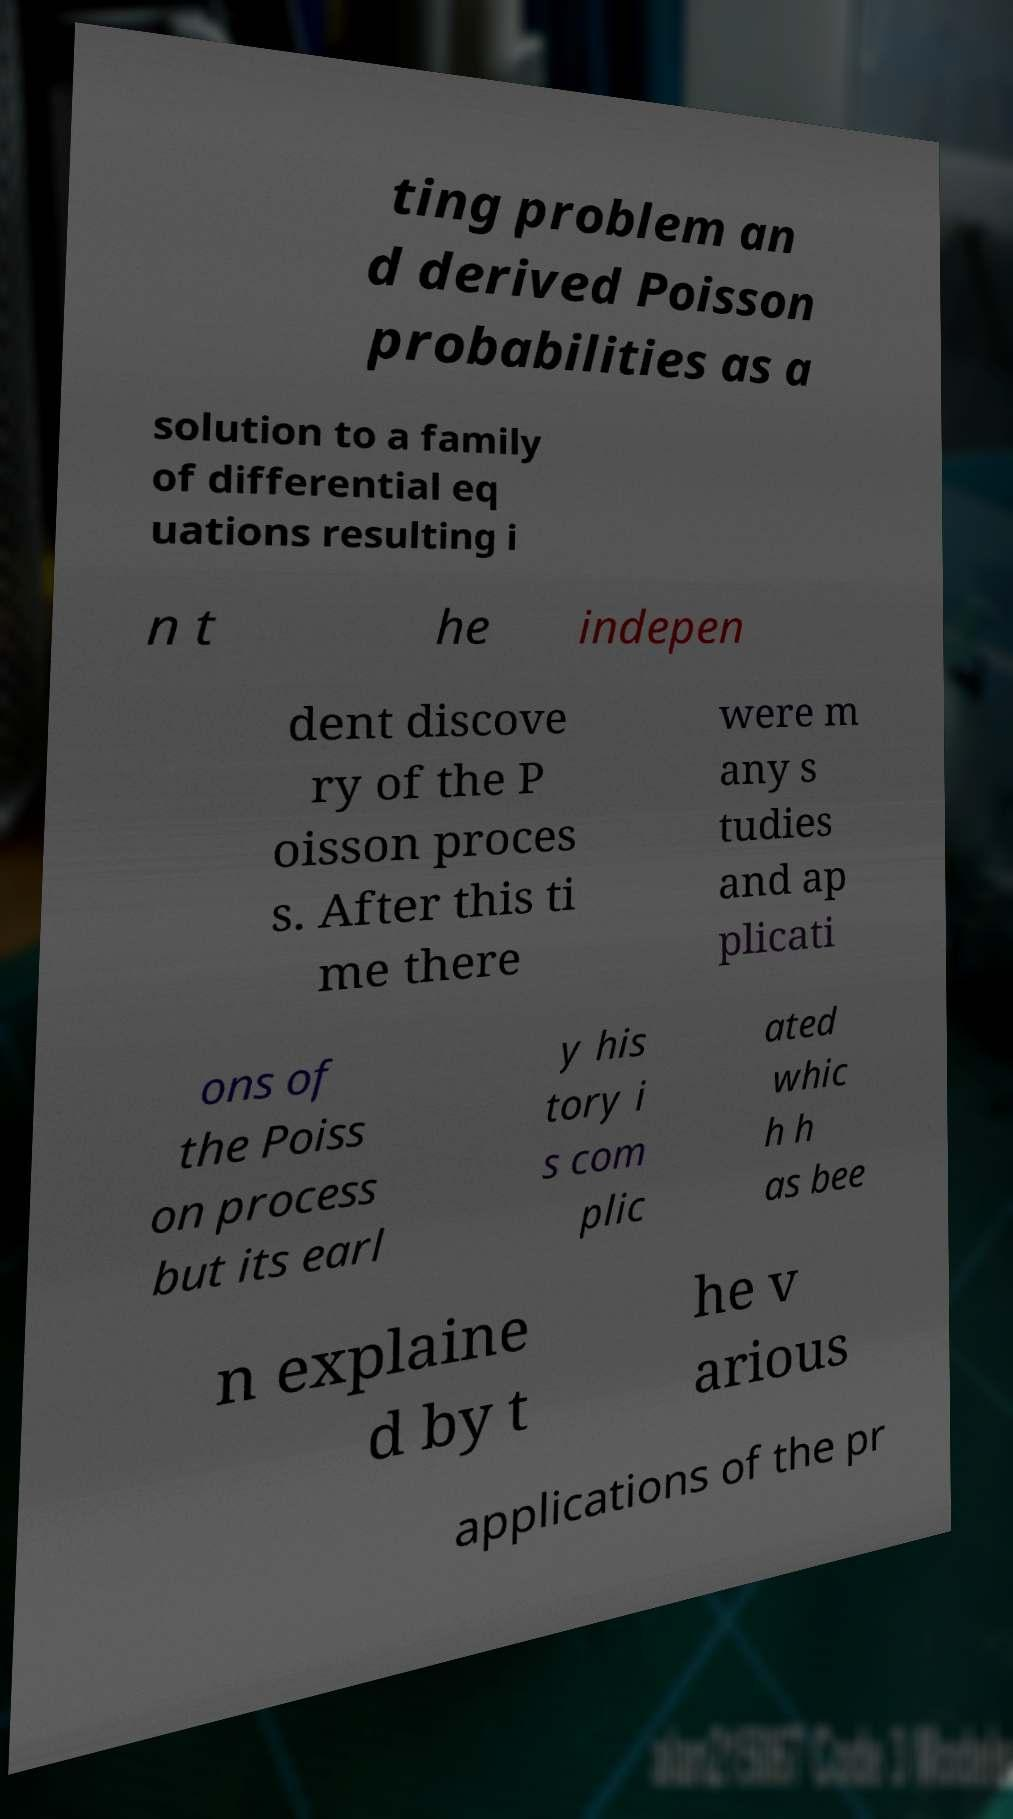For documentation purposes, I need the text within this image transcribed. Could you provide that? ting problem an d derived Poisson probabilities as a solution to a family of differential eq uations resulting i n t he indepen dent discove ry of the P oisson proces s. After this ti me there were m any s tudies and ap plicati ons of the Poiss on process but its earl y his tory i s com plic ated whic h h as bee n explaine d by t he v arious applications of the pr 